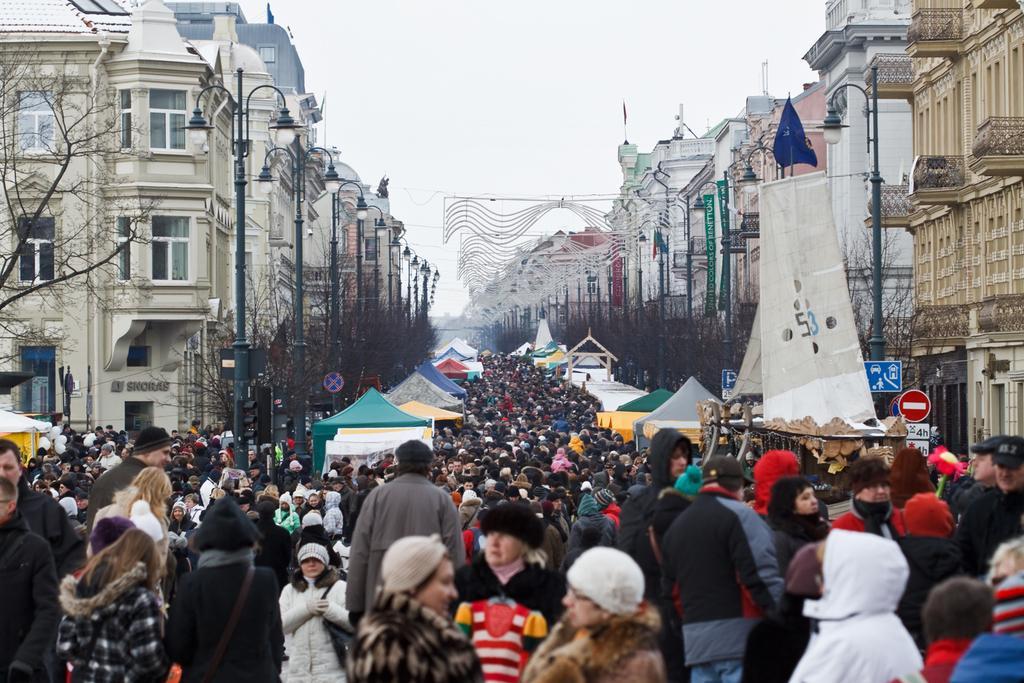Could you give a brief overview of what you see in this image? In this image at the bottom, there is a woman, she wears a dress, in front of her there is a woman. In the middle there are many people, street lights, tents, posters, signboards, trees, buildings, windows, flags. At the top there is the sky. 